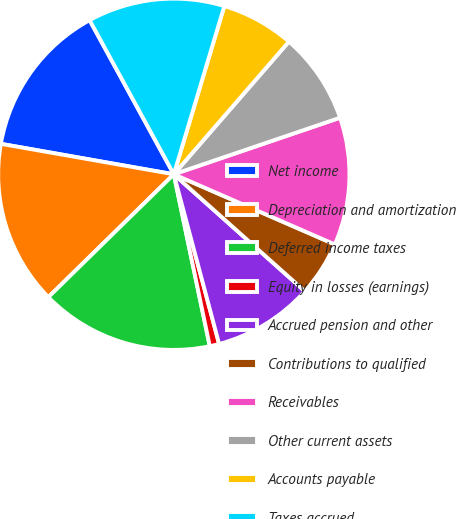Convert chart to OTSL. <chart><loc_0><loc_0><loc_500><loc_500><pie_chart><fcel>Net income<fcel>Depreciation and amortization<fcel>Deferred income taxes<fcel>Equity in losses (earnings)<fcel>Accrued pension and other<fcel>Contributions to qualified<fcel>Receivables<fcel>Other current assets<fcel>Accounts payable<fcel>Taxes accrued<nl><fcel>14.27%<fcel>15.11%<fcel>15.95%<fcel>0.87%<fcel>9.25%<fcel>5.06%<fcel>11.76%<fcel>8.41%<fcel>6.73%<fcel>12.6%<nl></chart> 